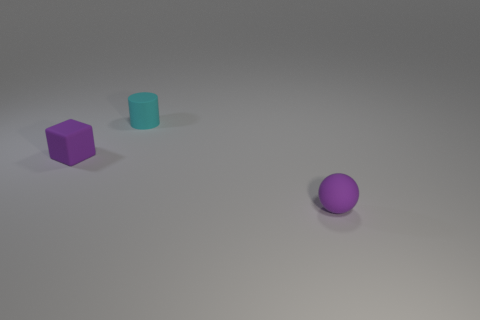Add 1 purple rubber objects. How many objects exist? 4 Subtract all spheres. How many objects are left? 2 Add 1 purple rubber blocks. How many purple rubber blocks exist? 2 Subtract 0 gray cylinders. How many objects are left? 3 Subtract all small purple matte blocks. Subtract all big blue spheres. How many objects are left? 2 Add 3 tiny purple blocks. How many tiny purple blocks are left? 4 